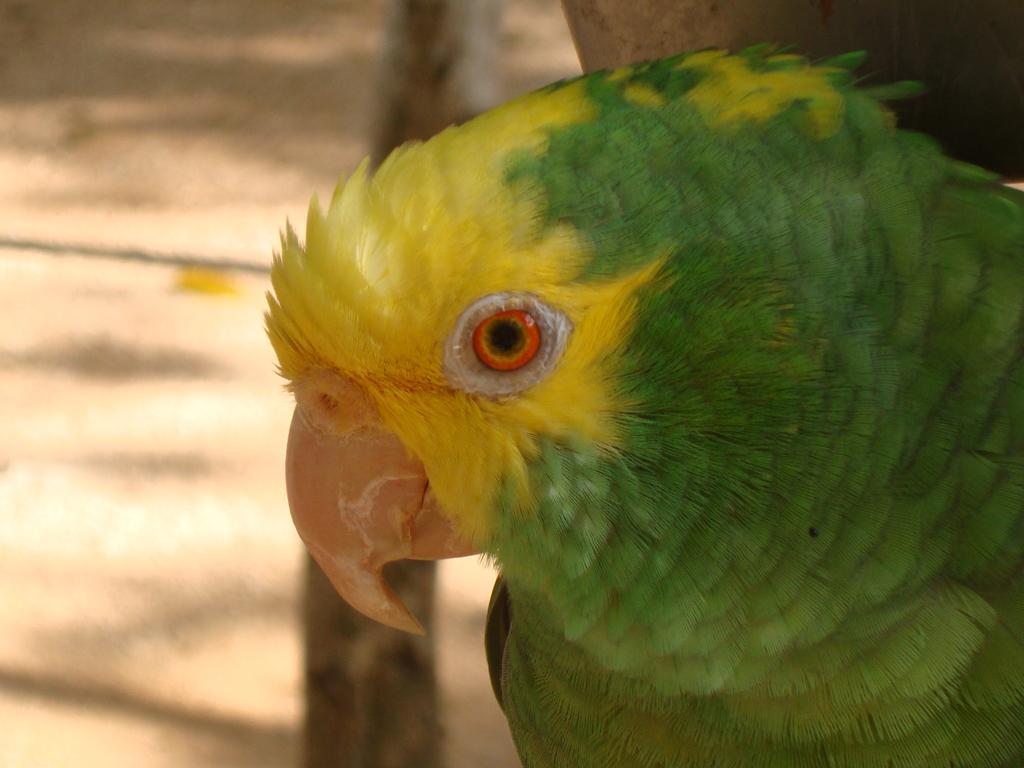Could you give a brief overview of what you see in this image? On the right side of the image we can see a budgerigar. In the background of the image we can see the ground and log. 